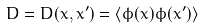Convert formula to latex. <formula><loc_0><loc_0><loc_500><loc_500>D = D ( x , x ^ { \prime } ) = \langle \phi ( x ) \phi ( x ^ { \prime } ) \rangle</formula> 